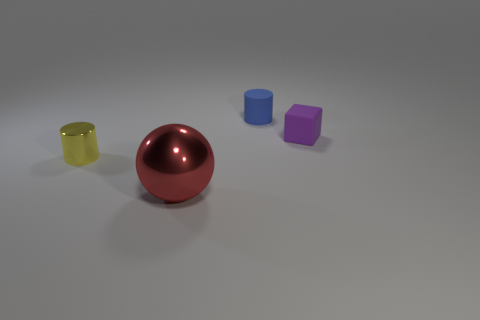Add 2 small green cylinders. How many objects exist? 6 Subtract all cubes. How many objects are left? 3 Add 4 small blocks. How many small blocks exist? 5 Subtract 0 brown blocks. How many objects are left? 4 Subtract all tiny blue rubber things. Subtract all tiny yellow shiny things. How many objects are left? 2 Add 1 shiny cylinders. How many shiny cylinders are left? 2 